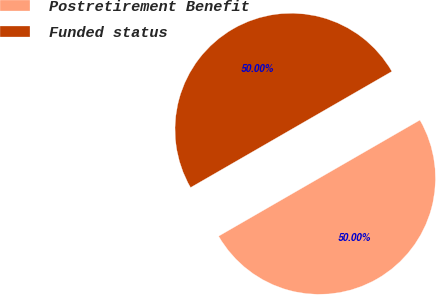Convert chart to OTSL. <chart><loc_0><loc_0><loc_500><loc_500><pie_chart><fcel>Postretirement Benefit<fcel>Funded status<nl><fcel>50.0%<fcel>50.0%<nl></chart> 